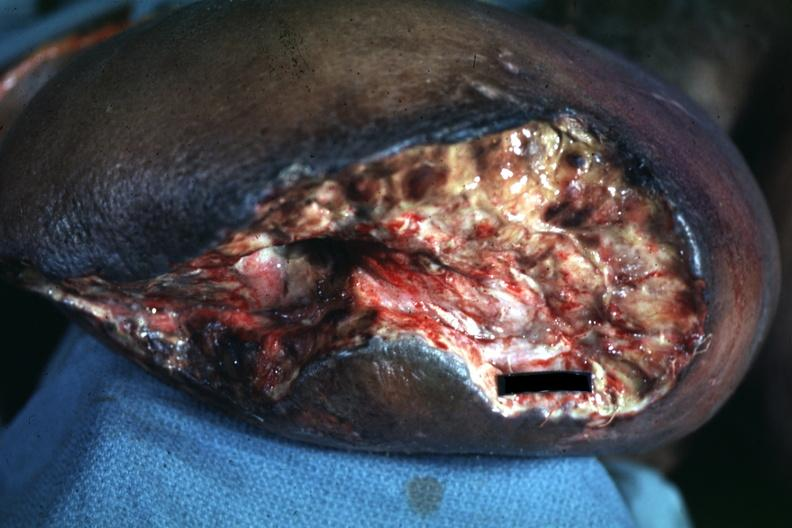does wound appear to be mid thigh?
Answer the question using a single word or phrase. Yes 